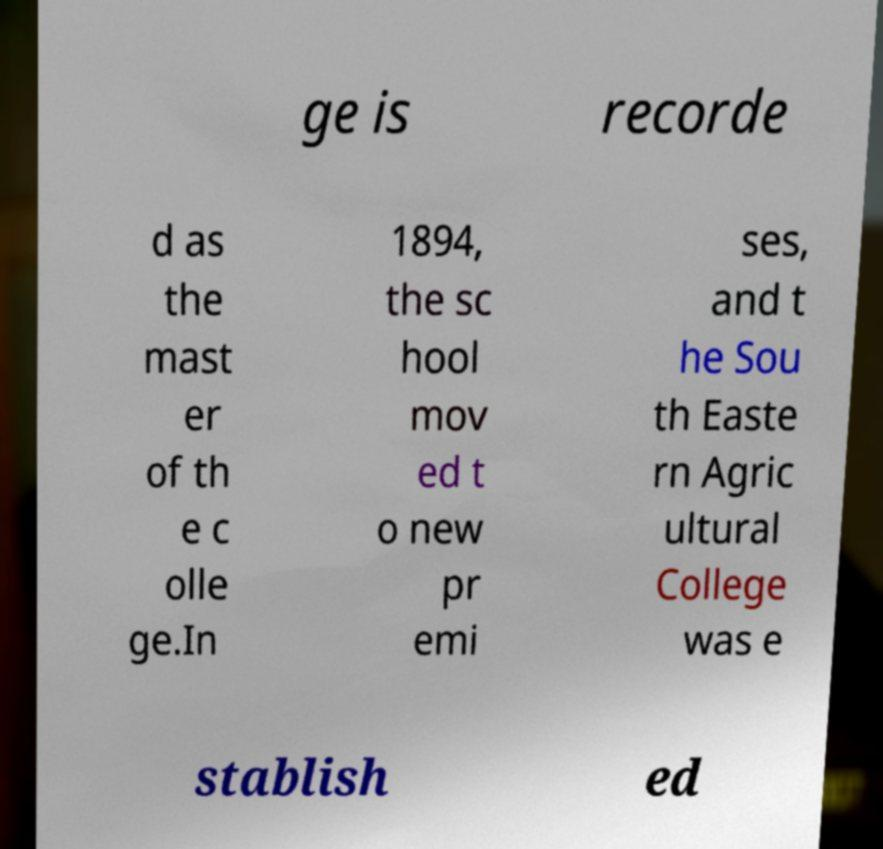Please identify and transcribe the text found in this image. ge is recorde d as the mast er of th e c olle ge.In 1894, the sc hool mov ed t o new pr emi ses, and t he Sou th Easte rn Agric ultural College was e stablish ed 